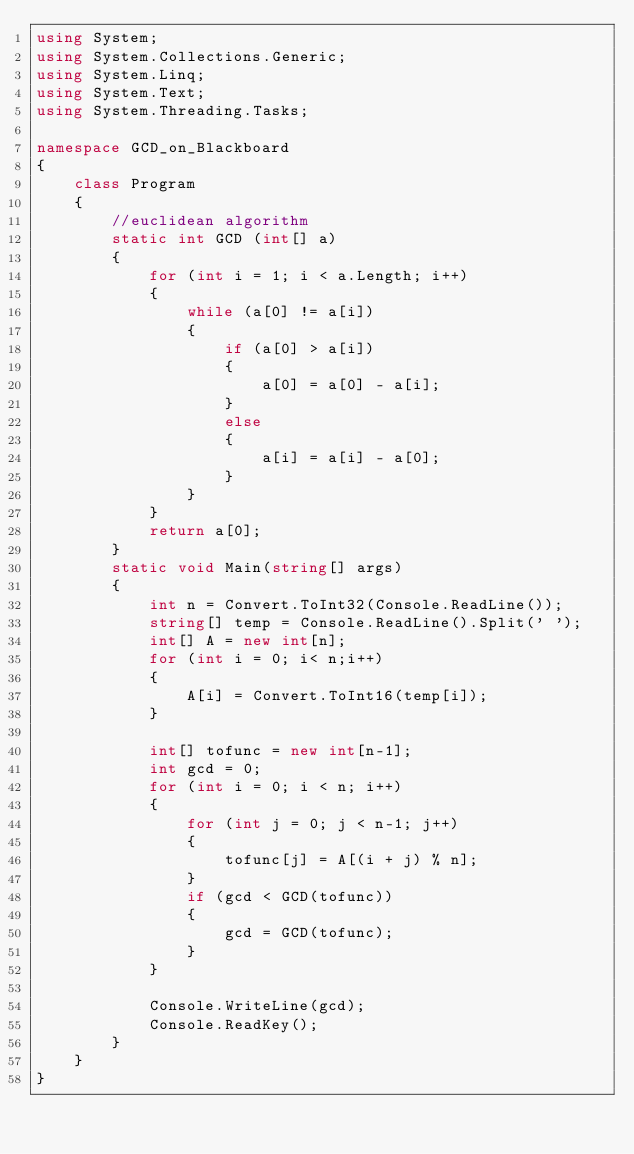<code> <loc_0><loc_0><loc_500><loc_500><_C#_>using System;
using System.Collections.Generic;
using System.Linq;
using System.Text;
using System.Threading.Tasks;

namespace GCD_on_Blackboard
{
    class Program
    {
        //euclidean algorithm
        static int GCD (int[] a)
        {
            for (int i = 1; i < a.Length; i++)
            {
                while (a[0] != a[i]) 
                {
                    if (a[0] > a[i])
                    {
                        a[0] = a[0] - a[i];
                    }
                    else
                    {
                        a[i] = a[i] - a[0];
                    }
                }        
            }
            return a[0];
        }
        static void Main(string[] args)
        {
            int n = Convert.ToInt32(Console.ReadLine());
            string[] temp = Console.ReadLine().Split(' ');
            int[] A = new int[n];
            for (int i = 0; i< n;i++)
            {
                A[i] = Convert.ToInt16(temp[i]);
            }

            int[] tofunc = new int[n-1];
            int gcd = 0;
            for (int i = 0; i < n; i++)
            {
                for (int j = 0; j < n-1; j++)
                {
                    tofunc[j] = A[(i + j) % n];
                }
                if (gcd < GCD(tofunc))
                {
                    gcd = GCD(tofunc);
                }
            }

            Console.WriteLine(gcd);
            Console.ReadKey();
        }
    }
}
</code> 